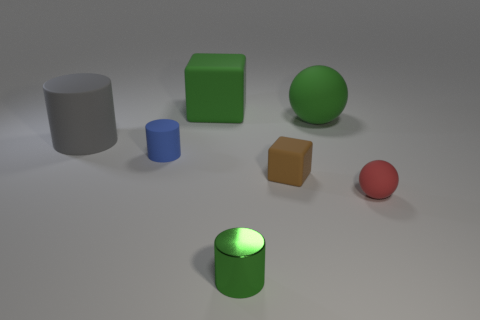Add 1 green cubes. How many objects exist? 8 Subtract all cylinders. How many objects are left? 4 Subtract all large green things. Subtract all tiny rubber cylinders. How many objects are left? 4 Add 3 small blue matte objects. How many small blue matte objects are left? 4 Add 2 large gray rubber objects. How many large gray rubber objects exist? 3 Subtract 1 gray cylinders. How many objects are left? 6 